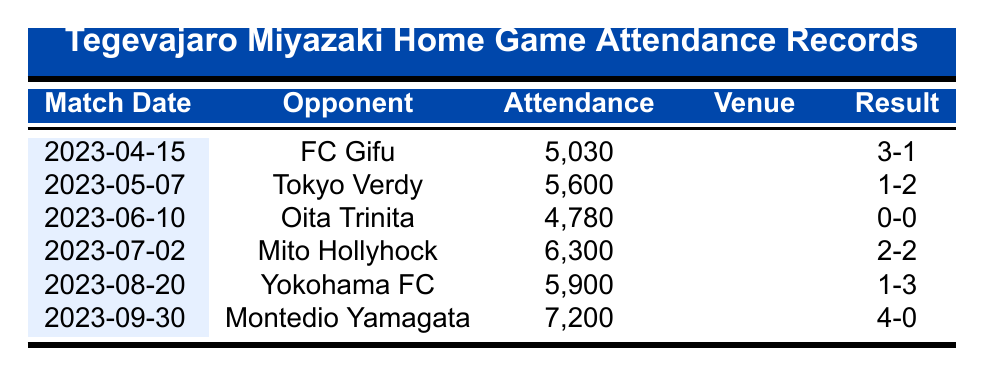What was the attendance at the match against FC Gifu? The table lists the match against FC Gifu on April 15, 2023, with an attendance of 5,030.
Answer: 5,030 Which match had the highest attendance? The match against Montedio Yamagata on September 30, 2023, had the highest attendance of 7,200, as it is the largest number in the Attendance column.
Answer: 7,200 Was there a match with a score of 0-0? The match against Oita Trinita on June 10, 2023, resulted in a score of 0-0. This indicates that no goals were scored during the match.
Answer: Yes What is the total attendance for all matches listed? The total attendance can be calculated by summing all the attendance figures: 5,030 + 5,600 + 4,780 + 6,300 + 5,900 + 7,200 = 34,810.
Answer: 34,810 How many matches had an attendance exceeding 6,000? In the table, there are three matches with attendances over 6,000 (against Mito Hollyhock, Yokohama FC, and Montedio Yamagata). We can count them to find the answer.
Answer: 3 What was the average attendance across all matches? The average attendance is calculated by summing the total attendance (34,810) and dividing by the number of matches (6): 34,810 / 6 = 5,802.
Answer: 5,802 Did Tegevajaro Miyazaki win more matches than they lost? To find this, we look at the match results. They won against FC Gifu, and Montedio Yamagata, drew with Mito Hollyhock, and lost to Tokyo Verdy, Yokohama FC. So, they won 2, lost 2, and drew 1 which means they did not win more than they lost.
Answer: No What is the difference in attendance between the match against FC Gifu and the match against Montedio Yamagata? The attendance for FC Gifu was 5,030 and for Montedio Yamagata was 7,200. The difference is calculated as 7,200 - 5,030 = 2,170.
Answer: 2,170 Which opponent had the lowest attendance in their match? Oita Trinita had the lowest attendance of 4,780 in their match on June 10, 2023. This can be found by checking all the attendance values in the table.
Answer: Oita Trinita 